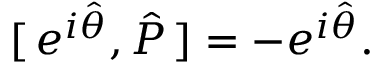Convert formula to latex. <formula><loc_0><loc_0><loc_500><loc_500>[ \, e ^ { i \hat { \theta } } , \hat { P } \, ] = - e ^ { i \hat { \theta } } .</formula> 